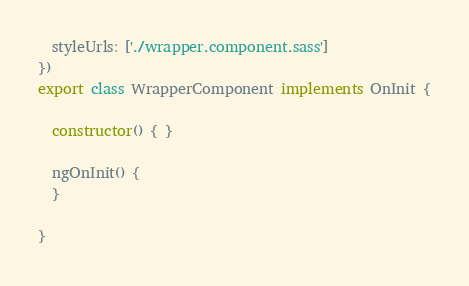<code> <loc_0><loc_0><loc_500><loc_500><_TypeScript_>  styleUrls: ['./wrapper.component.sass']
})
export class WrapperComponent implements OnInit {

  constructor() { }

  ngOnInit() {
  }

}
</code> 